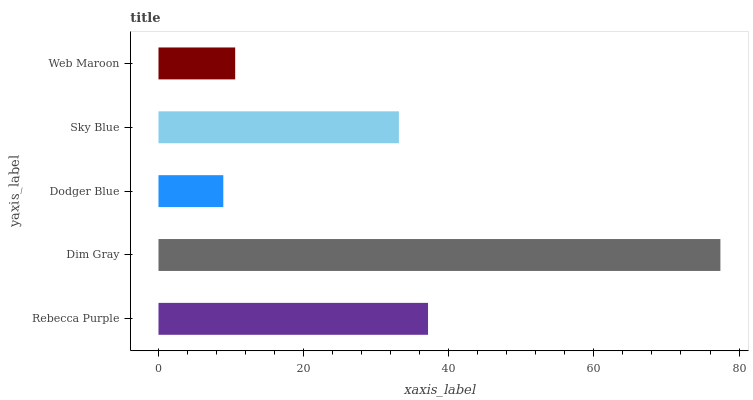Is Dodger Blue the minimum?
Answer yes or no. Yes. Is Dim Gray the maximum?
Answer yes or no. Yes. Is Dim Gray the minimum?
Answer yes or no. No. Is Dodger Blue the maximum?
Answer yes or no. No. Is Dim Gray greater than Dodger Blue?
Answer yes or no. Yes. Is Dodger Blue less than Dim Gray?
Answer yes or no. Yes. Is Dodger Blue greater than Dim Gray?
Answer yes or no. No. Is Dim Gray less than Dodger Blue?
Answer yes or no. No. Is Sky Blue the high median?
Answer yes or no. Yes. Is Sky Blue the low median?
Answer yes or no. Yes. Is Rebecca Purple the high median?
Answer yes or no. No. Is Dim Gray the low median?
Answer yes or no. No. 